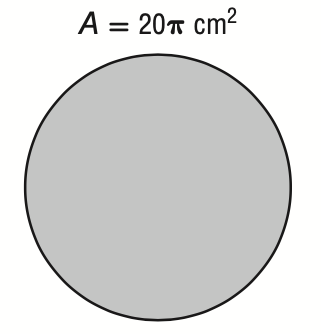Question: The area of a circle is 20 \pi square centimeters. What is its circumference?
Choices:
A. \sqrt 5 \pi
B. 2 \sqrt 5 \pi
C. 4 \sqrt 5 \pi
D. 20 \pi
Answer with the letter. Answer: C 